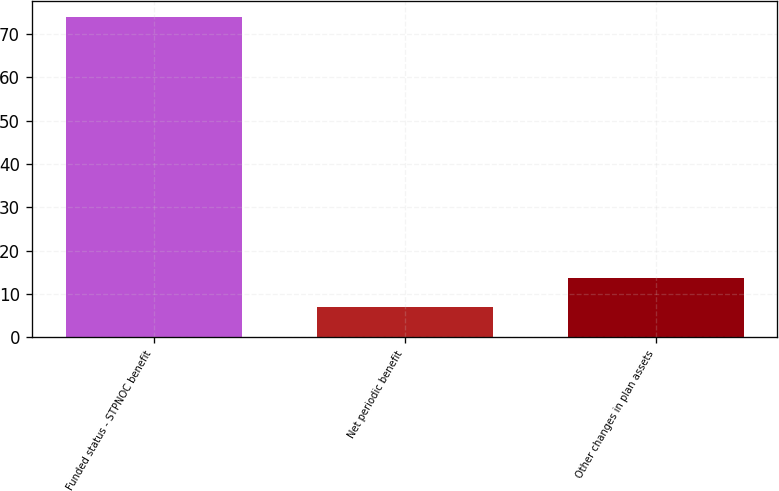Convert chart. <chart><loc_0><loc_0><loc_500><loc_500><bar_chart><fcel>Funded status - STPNOC benefit<fcel>Net periodic benefit<fcel>Other changes in plan assets<nl><fcel>74<fcel>7<fcel>13.7<nl></chart> 